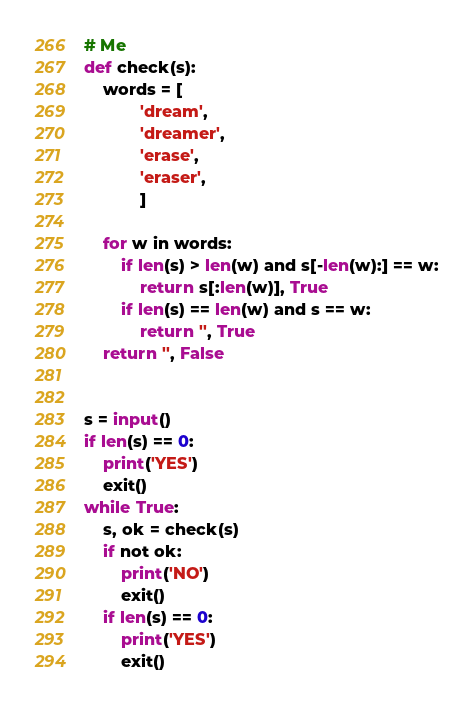Convert code to text. <code><loc_0><loc_0><loc_500><loc_500><_Python_># Me
def check(s):
    words = [
            'dream',
            'dreamer',
            'erase',
            'eraser',
            ]

    for w in words:
        if len(s) > len(w) and s[-len(w):] == w:
            return s[:len(w)], True
        if len(s) == len(w) and s == w:
            return '', True
    return '', False


s = input()
if len(s) == 0:
    print('YES')
    exit()
while True:
    s, ok = check(s)
    if not ok:
        print('NO')
        exit()
    if len(s) == 0:
        print('YES')
        exit()
</code> 